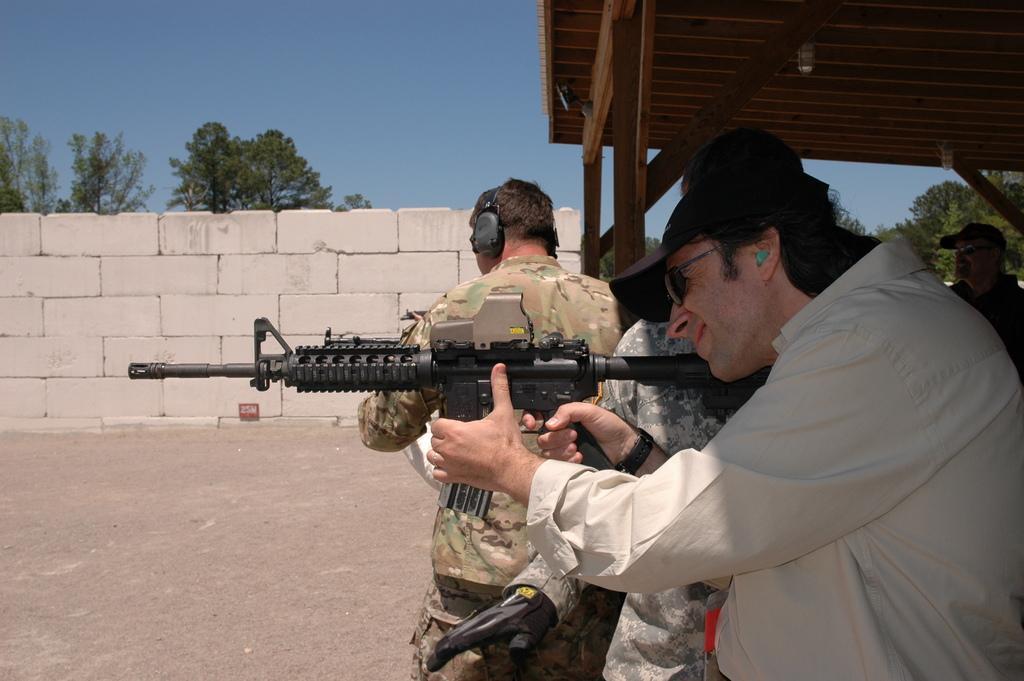Can you describe this image briefly? In this picture I can see few people are standing under the shelter. I can see a man holding a gun in his hand and he is wearing a cap and sunglasses, another man is wearing a headset. I can see trees and a wall in the background and I can see a blue sky. 